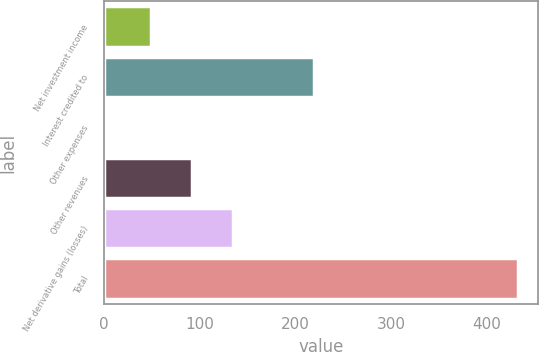<chart> <loc_0><loc_0><loc_500><loc_500><bar_chart><fcel>Net investment income<fcel>Interest credited to<fcel>Other expenses<fcel>Other revenues<fcel>Net derivative gains (losses)<fcel>Total<nl><fcel>49<fcel>220<fcel>3<fcel>91.9<fcel>134.8<fcel>432<nl></chart> 